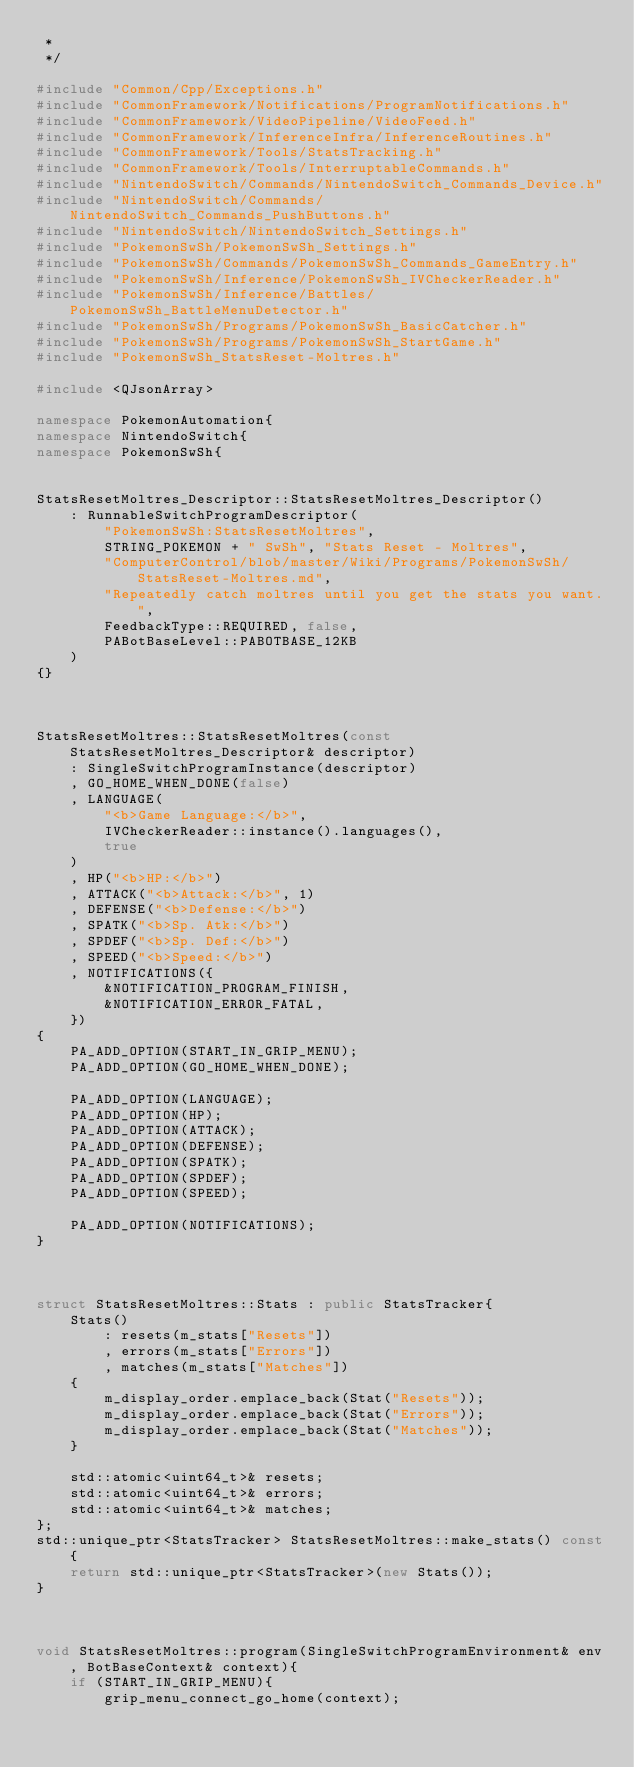<code> <loc_0><loc_0><loc_500><loc_500><_C++_> *
 */

#include "Common/Cpp/Exceptions.h"
#include "CommonFramework/Notifications/ProgramNotifications.h"
#include "CommonFramework/VideoPipeline/VideoFeed.h"
#include "CommonFramework/InferenceInfra/InferenceRoutines.h"
#include "CommonFramework/Tools/StatsTracking.h"
#include "CommonFramework/Tools/InterruptableCommands.h"
#include "NintendoSwitch/Commands/NintendoSwitch_Commands_Device.h"
#include "NintendoSwitch/Commands/NintendoSwitch_Commands_PushButtons.h"
#include "NintendoSwitch/NintendoSwitch_Settings.h"
#include "PokemonSwSh/PokemonSwSh_Settings.h"
#include "PokemonSwSh/Commands/PokemonSwSh_Commands_GameEntry.h"
#include "PokemonSwSh/Inference/PokemonSwSh_IVCheckerReader.h"
#include "PokemonSwSh/Inference/Battles/PokemonSwSh_BattleMenuDetector.h"
#include "PokemonSwSh/Programs/PokemonSwSh_BasicCatcher.h"
#include "PokemonSwSh/Programs/PokemonSwSh_StartGame.h"
#include "PokemonSwSh_StatsReset-Moltres.h"

#include <QJsonArray>

namespace PokemonAutomation{
namespace NintendoSwitch{
namespace PokemonSwSh{


StatsResetMoltres_Descriptor::StatsResetMoltres_Descriptor()
    : RunnableSwitchProgramDescriptor(
        "PokemonSwSh:StatsResetMoltres",
        STRING_POKEMON + " SwSh", "Stats Reset - Moltres",
        "ComputerControl/blob/master/Wiki/Programs/PokemonSwSh/StatsReset-Moltres.md",
        "Repeatedly catch moltres until you get the stats you want.",
        FeedbackType::REQUIRED, false,
        PABotBaseLevel::PABOTBASE_12KB
    )
{}



StatsResetMoltres::StatsResetMoltres(const StatsResetMoltres_Descriptor& descriptor)
    : SingleSwitchProgramInstance(descriptor)
    , GO_HOME_WHEN_DONE(false)
    , LANGUAGE(
        "<b>Game Language:</b>",
        IVCheckerReader::instance().languages(),
        true
    )
    , HP("<b>HP:</b>")
    , ATTACK("<b>Attack:</b>", 1)
    , DEFENSE("<b>Defense:</b>")
    , SPATK("<b>Sp. Atk:</b>")
    , SPDEF("<b>Sp. Def:</b>")
    , SPEED("<b>Speed:</b>")
    , NOTIFICATIONS({
        &NOTIFICATION_PROGRAM_FINISH,
        &NOTIFICATION_ERROR_FATAL,
    })
{
    PA_ADD_OPTION(START_IN_GRIP_MENU);
    PA_ADD_OPTION(GO_HOME_WHEN_DONE);

    PA_ADD_OPTION(LANGUAGE);
    PA_ADD_OPTION(HP);
    PA_ADD_OPTION(ATTACK);
    PA_ADD_OPTION(DEFENSE);
    PA_ADD_OPTION(SPATK);
    PA_ADD_OPTION(SPDEF);
    PA_ADD_OPTION(SPEED);

    PA_ADD_OPTION(NOTIFICATIONS);
}



struct StatsResetMoltres::Stats : public StatsTracker{
    Stats()
        : resets(m_stats["Resets"])
        , errors(m_stats["Errors"])
        , matches(m_stats["Matches"])
    {
        m_display_order.emplace_back(Stat("Resets"));
        m_display_order.emplace_back(Stat("Errors"));
        m_display_order.emplace_back(Stat("Matches"));
    }

    std::atomic<uint64_t>& resets;
    std::atomic<uint64_t>& errors;
    std::atomic<uint64_t>& matches;
};
std::unique_ptr<StatsTracker> StatsResetMoltres::make_stats() const{
    return std::unique_ptr<StatsTracker>(new Stats());
}



void StatsResetMoltres::program(SingleSwitchProgramEnvironment& env, BotBaseContext& context){
    if (START_IN_GRIP_MENU){
        grip_menu_connect_go_home(context);</code> 